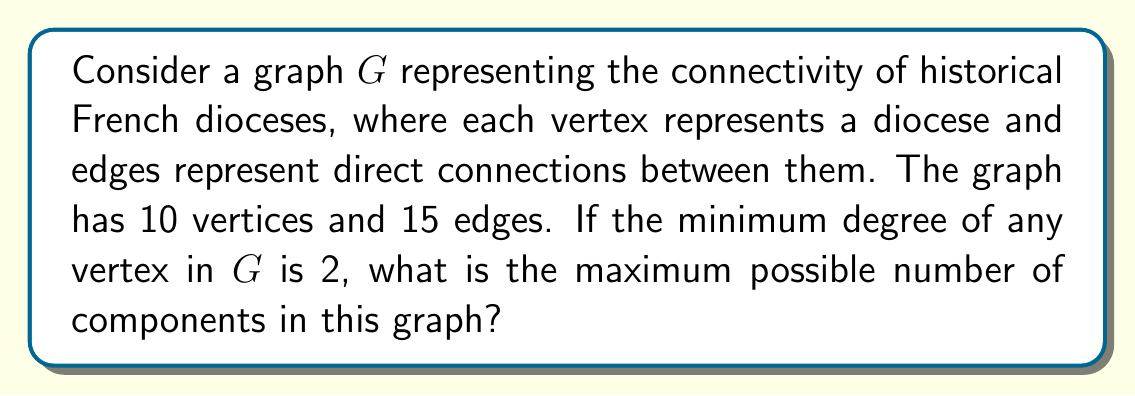Teach me how to tackle this problem. To solve this problem, we need to consider the following steps:

1) First, recall that in graph theory, a component is a maximal connected subgraph. We're looking for the maximum number of components possible given the constraints.

2) We have 10 vertices ($n = 10$) and 15 edges ($m = 15$).

3) The minimum degree of any vertex is 2, which means each diocese is connected to at least two others.

4) To maximize the number of components, we want to create as many separate subgraphs as possible while still satisfying the given conditions.

5) The smallest possible component that satisfies the minimum degree requirement is a cycle of 3 vertices. This uses 3 edges.

6) Let's denote the number of components as $k$. We can set up an inequality:

   $3k \leq m = 15$

   This is because each component must have at least 3 edges.

7) Solving this inequality:

   $k \leq 5$

8) However, we need to check if this is actually possible with 10 vertices.

9) The maximum number of components ($k = 5$) would require five 3-vertex cycles, which uses exactly 15 vertices (5 * 3 = 15).

10) Since we only have 10 vertices, this is not possible. The actual maximum number of components will be less.

11) The largest number of components possible with 10 vertices that satisfies all conditions is 3:
    - Two 3-vertex cycles (6 vertices, 6 edges)
    - One 4-vertex component (4 vertices, at least 4 edges)

    This configuration uses all 10 vertices and at least 10 edges, leaving room for additional edges to reach the total of 15 while maintaining the minimum degree of 2 for all vertices.

Therefore, the maximum possible number of components in this graph is 3.
Answer: 3 components 